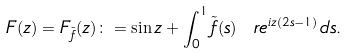<formula> <loc_0><loc_0><loc_500><loc_500>F ( z ) = F _ { \tilde { f } } ( z ) \colon = \sin z + \int _ { 0 } ^ { 1 } \tilde { f } ( s ) \ r e ^ { i z ( 2 s - 1 ) } \, d s .</formula> 